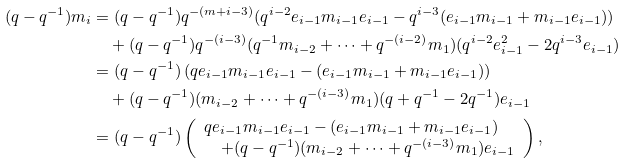<formula> <loc_0><loc_0><loc_500><loc_500>( q - q ^ { - 1 } ) m _ { i } & = ( q - q ^ { - 1 } ) q ^ { - ( m + i - 3 ) } ( q ^ { i - 2 } e _ { i - 1 } m _ { i - 1 } e _ { i - 1 } - q ^ { i - 3 } ( e _ { i - 1 } m _ { i - 1 } + m _ { i - 1 } e _ { i - 1 } ) ) \\ & \quad + ( q - q ^ { - 1 } ) q ^ { - ( i - 3 ) } ( q ^ { - 1 } m _ { i - 2 } + \cdots + q ^ { - ( i - 2 ) } m _ { 1 } ) ( q ^ { i - 2 } e _ { i - 1 } ^ { 2 } - 2 q ^ { i - 3 } e _ { i - 1 } ) \\ & = ( q - q ^ { - 1 } ) \left ( q e _ { i - 1 } m _ { i - 1 } e _ { i - 1 } - ( e _ { i - 1 } m _ { i - 1 } + m _ { i - 1 } e _ { i - 1 } ) \right ) \\ & \quad + ( q - q ^ { - 1 } ) ( m _ { i - 2 } + \cdots + q ^ { - ( i - 3 ) } m _ { 1 } ) ( q + q ^ { - 1 } - 2 q ^ { - 1 } ) e _ { i - 1 } \\ & = ( q - q ^ { - 1 } ) \left ( \begin{array} { l } q e _ { i - 1 } m _ { i - 1 } e _ { i - 1 } - ( e _ { i - 1 } m _ { i - 1 } + m _ { i - 1 } e _ { i - 1 } ) \\ \quad + ( q - q ^ { - 1 } ) ( m _ { i - 2 } + \cdots + q ^ { - ( i - 3 ) } m _ { 1 } ) e _ { i - 1 } \end{array} \right ) ,</formula> 